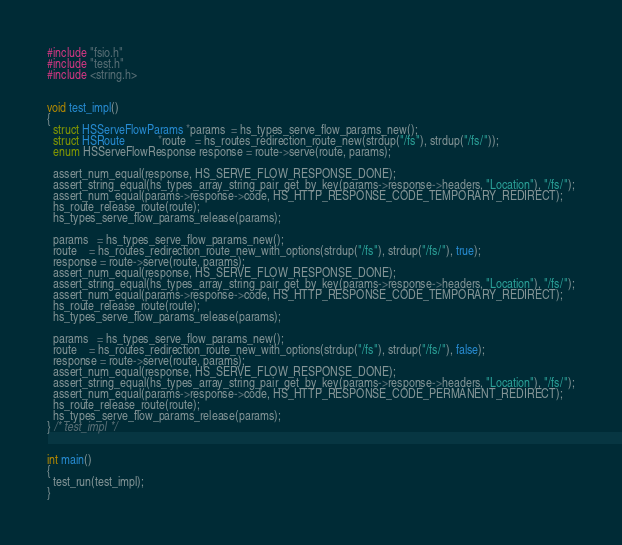<code> <loc_0><loc_0><loc_500><loc_500><_C_>#include "fsio.h"
#include "test.h"
#include <string.h>


void test_impl()
{
  struct HSServeFlowParams *params  = hs_types_serve_flow_params_new();
  struct HSRoute           *route   = hs_routes_redirection_route_new(strdup("/fs"), strdup("/fs/"));
  enum HSServeFlowResponse response = route->serve(route, params);

  assert_num_equal(response, HS_SERVE_FLOW_RESPONSE_DONE);
  assert_string_equal(hs_types_array_string_pair_get_by_key(params->response->headers, "Location"), "/fs/");
  assert_num_equal(params->response->code, HS_HTTP_RESPONSE_CODE_TEMPORARY_REDIRECT);
  hs_route_release_route(route);
  hs_types_serve_flow_params_release(params);

  params   = hs_types_serve_flow_params_new();
  route    = hs_routes_redirection_route_new_with_options(strdup("/fs"), strdup("/fs/"), true);
  response = route->serve(route, params);
  assert_num_equal(response, HS_SERVE_FLOW_RESPONSE_DONE);
  assert_string_equal(hs_types_array_string_pair_get_by_key(params->response->headers, "Location"), "/fs/");
  assert_num_equal(params->response->code, HS_HTTP_RESPONSE_CODE_TEMPORARY_REDIRECT);
  hs_route_release_route(route);
  hs_types_serve_flow_params_release(params);

  params   = hs_types_serve_flow_params_new();
  route    = hs_routes_redirection_route_new_with_options(strdup("/fs"), strdup("/fs/"), false);
  response = route->serve(route, params);
  assert_num_equal(response, HS_SERVE_FLOW_RESPONSE_DONE);
  assert_string_equal(hs_types_array_string_pair_get_by_key(params->response->headers, "Location"), "/fs/");
  assert_num_equal(params->response->code, HS_HTTP_RESPONSE_CODE_PERMANENT_REDIRECT);
  hs_route_release_route(route);
  hs_types_serve_flow_params_release(params);
} /* test_impl */


int main()
{
  test_run(test_impl);
}

</code> 